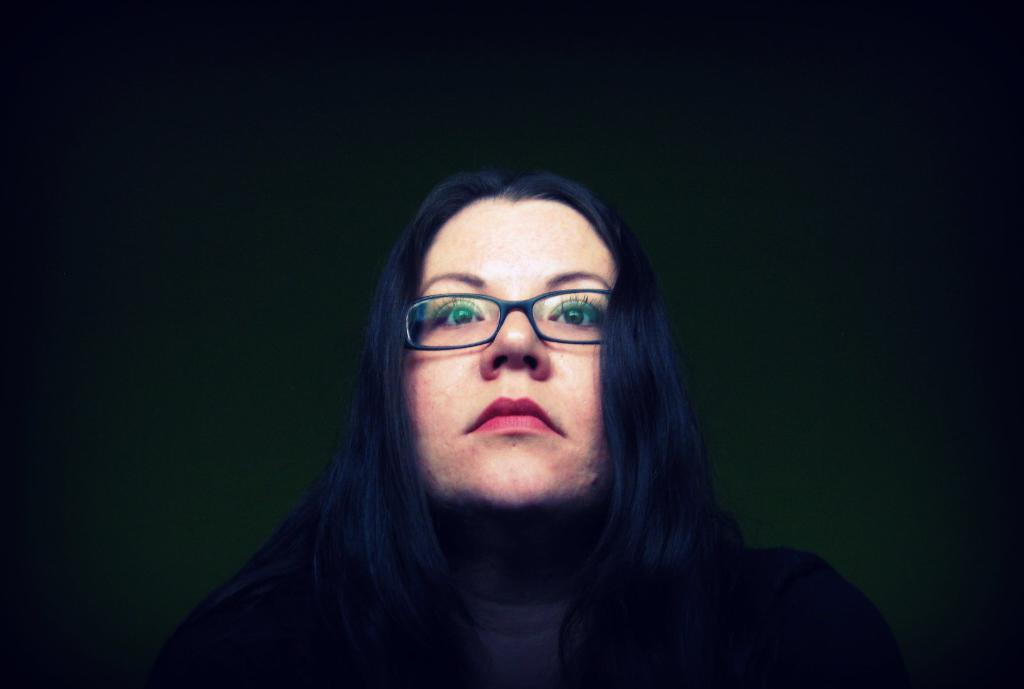Who is the main subject in the image? There is a woman in the image. What is the woman wearing? The woman is wearing spectacles. Where is the woman positioned in the image? The woman is standing in the front. What can be observed about the background of the image? The background of the image is blurred. How many eggs are visible in the image? There are no eggs present in the image. What type of tent is set up in the background of the image? There is no tent present in the image; the background is blurred. 